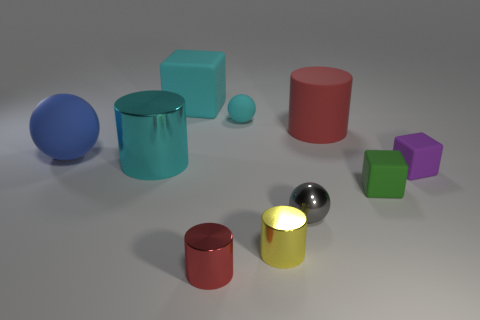What number of rubber things are either gray things or brown cubes?
Offer a terse response. 0. How many purple cubes are there?
Offer a terse response. 1. Do the tiny ball left of the yellow cylinder and the small block behind the tiny green thing have the same material?
Your response must be concise. Yes. There is another small thing that is the same shape as the green rubber thing; what is its color?
Your response must be concise. Purple. What material is the tiny sphere that is on the right side of the rubber ball that is to the right of the big cyan matte cube?
Make the answer very short. Metal. There is a tiny thing behind the large red rubber object; is its shape the same as the small matte thing in front of the purple block?
Provide a short and direct response. No. What is the size of the cube that is both on the right side of the tiny cyan rubber thing and to the left of the purple matte cube?
Keep it short and to the point. Small. What number of other things are the same color as the large matte sphere?
Keep it short and to the point. 0. Is the material of the sphere on the left side of the large cyan shiny thing the same as the cyan block?
Offer a very short reply. Yes. Is there anything else that has the same size as the matte cylinder?
Make the answer very short. Yes. 